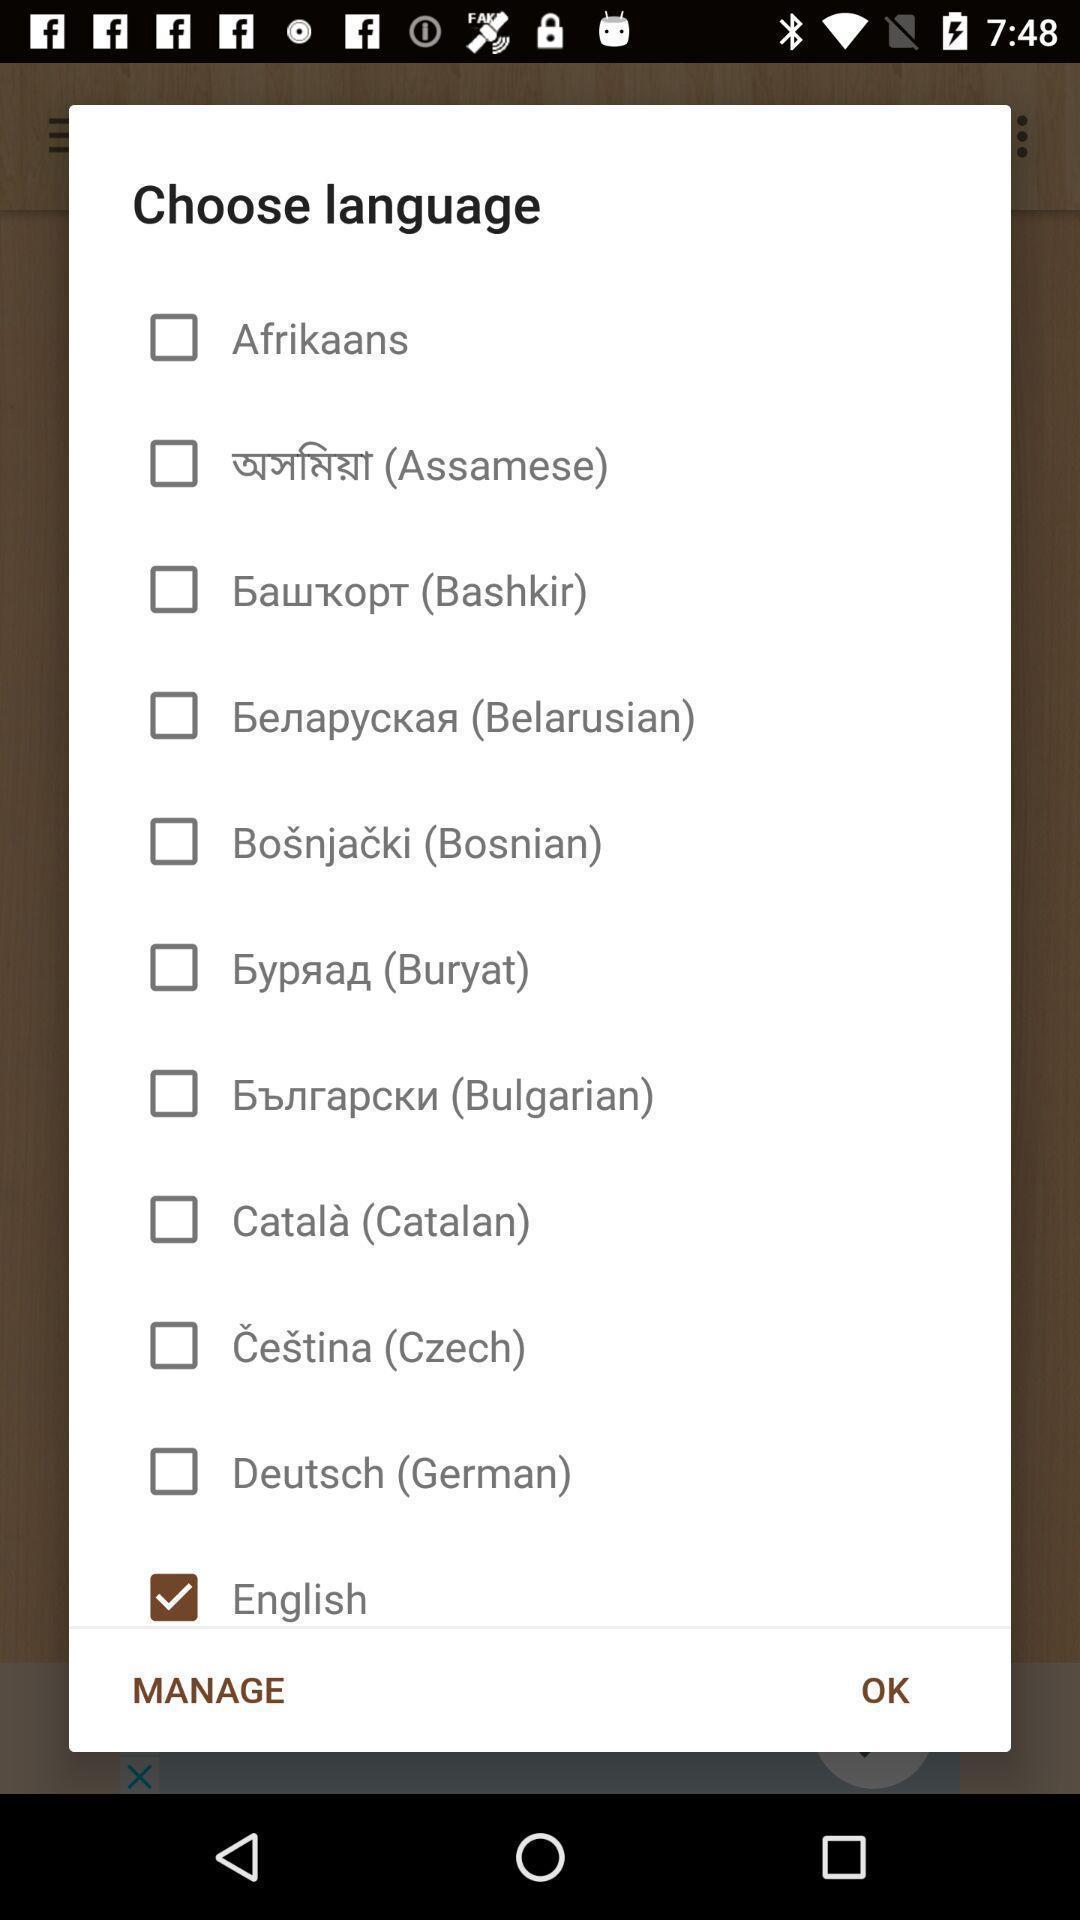What details can you identify in this image? Pop-up for the list of languages. 